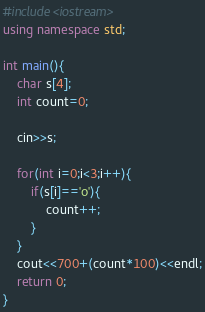<code> <loc_0><loc_0><loc_500><loc_500><_C++_>#include<iostream>
using namespace std;

int main(){
    char s[4];
    int count=0;

    cin>>s;

    for(int i=0;i<3;i++){
        if(s[i]=='o'){
            count++;
        }
    }
    cout<<700+(count*100)<<endl;
    return 0;
}</code> 